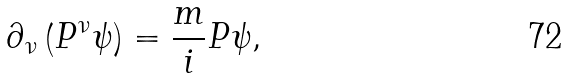<formula> <loc_0><loc_0><loc_500><loc_500>\partial _ { \nu } \left ( P ^ { \nu } \psi \right ) = \frac { m } { i } P \psi ,</formula> 